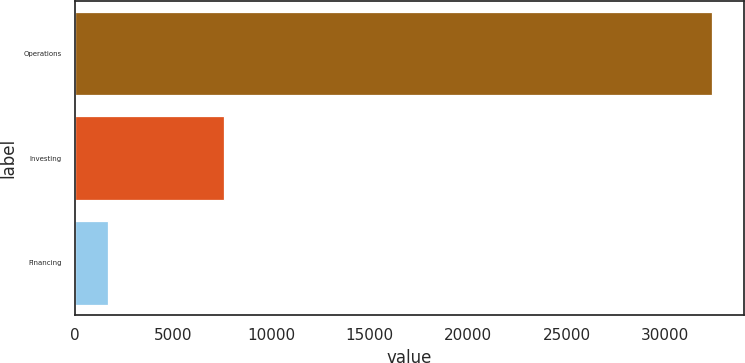<chart> <loc_0><loc_0><loc_500><loc_500><bar_chart><fcel>Operations<fcel>Investing<fcel>Financing<nl><fcel>32408<fcel>7618<fcel>1686<nl></chart> 